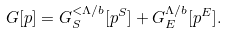<formula> <loc_0><loc_0><loc_500><loc_500>G [ p ] = G _ { S } ^ { < \Lambda / b } [ p ^ { S } ] + G _ { E } ^ { \Lambda / b } [ p ^ { E } ] .</formula> 